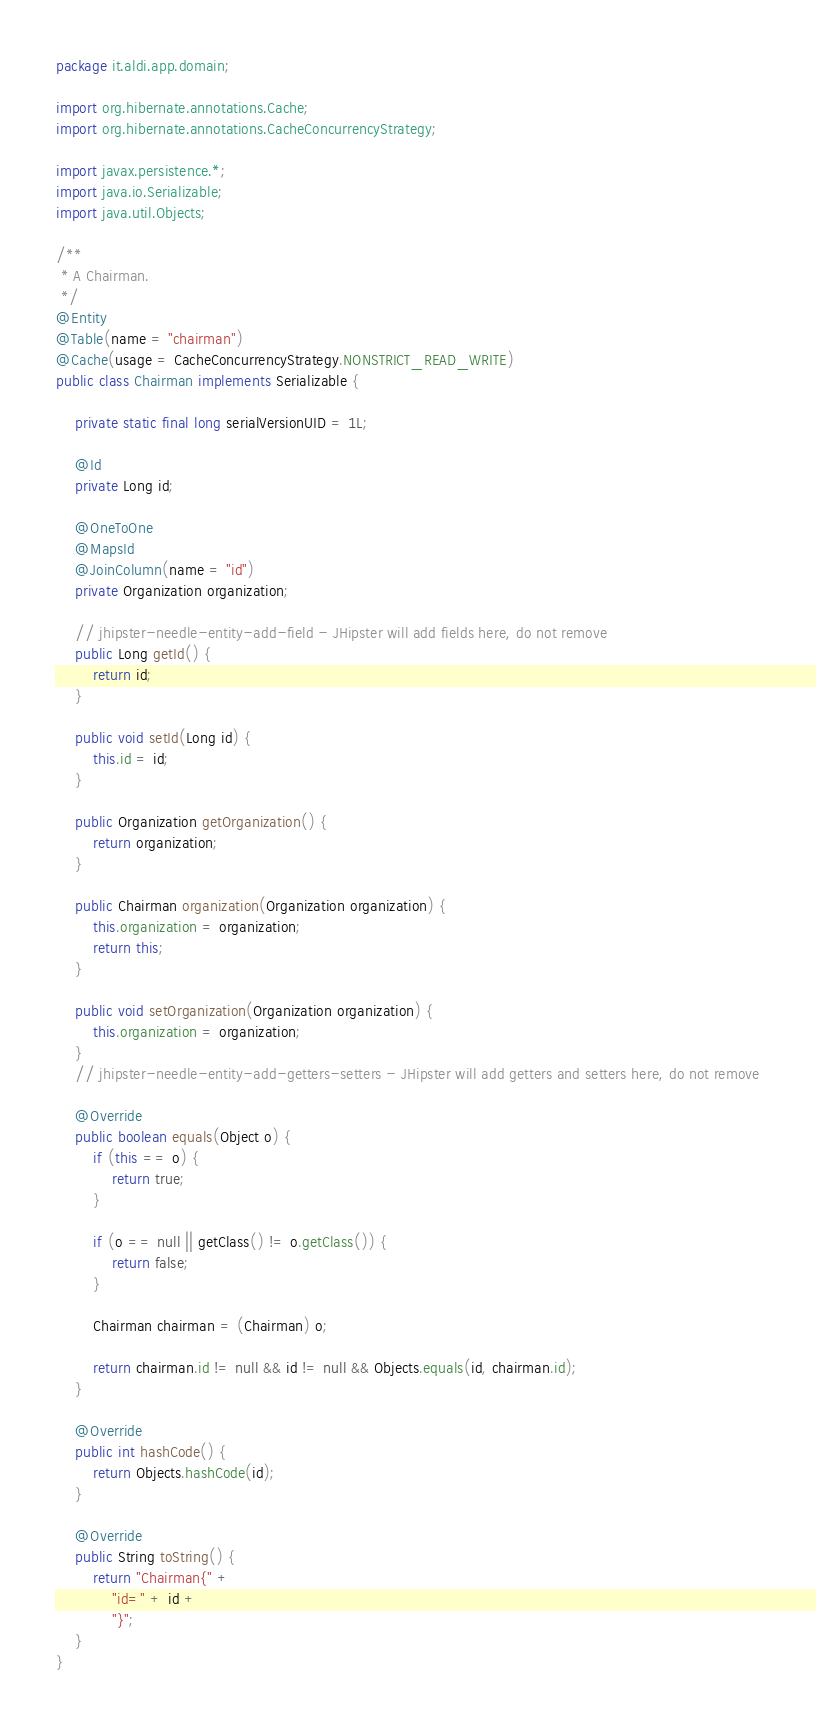Convert code to text. <code><loc_0><loc_0><loc_500><loc_500><_Java_>package it.aldi.app.domain;

import org.hibernate.annotations.Cache;
import org.hibernate.annotations.CacheConcurrencyStrategy;

import javax.persistence.*;
import java.io.Serializable;
import java.util.Objects;

/**
 * A Chairman.
 */
@Entity
@Table(name = "chairman")
@Cache(usage = CacheConcurrencyStrategy.NONSTRICT_READ_WRITE)
public class Chairman implements Serializable {

    private static final long serialVersionUID = 1L;

    @Id
    private Long id;

    @OneToOne
    @MapsId
    @JoinColumn(name = "id")
    private Organization organization;

    // jhipster-needle-entity-add-field - JHipster will add fields here, do not remove
    public Long getId() {
        return id;
    }

    public void setId(Long id) {
        this.id = id;
    }

    public Organization getOrganization() {
        return organization;
    }

    public Chairman organization(Organization organization) {
        this.organization = organization;
        return this;
    }

    public void setOrganization(Organization organization) {
        this.organization = organization;
    }
    // jhipster-needle-entity-add-getters-setters - JHipster will add getters and setters here, do not remove

    @Override
    public boolean equals(Object o) {
        if (this == o) {
            return true;
        }

        if (o == null || getClass() != o.getClass()) {
            return false;
        }

        Chairman chairman = (Chairman) o;

        return chairman.id != null && id != null && Objects.equals(id, chairman.id);
    }

    @Override
    public int hashCode() {
        return Objects.hashCode(id);
    }

    @Override
    public String toString() {
        return "Chairman{" +
            "id=" + id +
            "}";
    }
}
</code> 